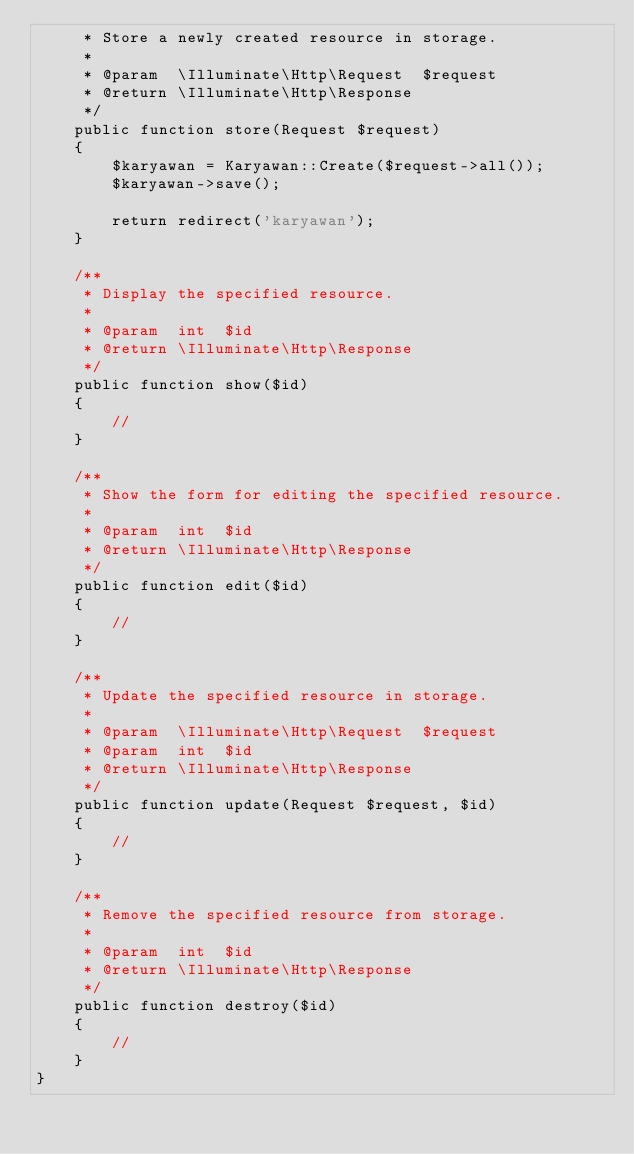<code> <loc_0><loc_0><loc_500><loc_500><_PHP_>     * Store a newly created resource in storage.
     *
     * @param  \Illuminate\Http\Request  $request
     * @return \Illuminate\Http\Response
     */
    public function store(Request $request)
    {
        $karyawan = Karyawan::Create($request->all());
        $karyawan->save();

        return redirect('karyawan');
    }

    /**
     * Display the specified resource.
     *
     * @param  int  $id
     * @return \Illuminate\Http\Response
     */
    public function show($id)
    {
        //
    }

    /**
     * Show the form for editing the specified resource.
     *
     * @param  int  $id
     * @return \Illuminate\Http\Response
     */
    public function edit($id)
    {
        //
    }

    /**
     * Update the specified resource in storage.
     *
     * @param  \Illuminate\Http\Request  $request
     * @param  int  $id
     * @return \Illuminate\Http\Response
     */
    public function update(Request $request, $id)
    {
        //
    }

    /**
     * Remove the specified resource from storage.
     *
     * @param  int  $id
     * @return \Illuminate\Http\Response
     */
    public function destroy($id)
    {
        //
    }
}
</code> 